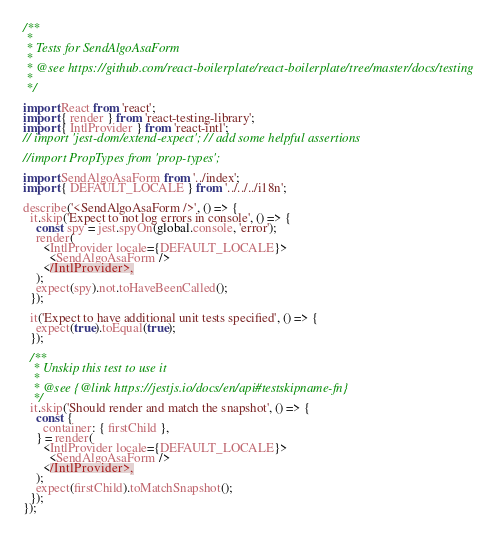Convert code to text. <code><loc_0><loc_0><loc_500><loc_500><_JavaScript_>/**
 *
 * Tests for SendAlgoAsaForm
 *
 * @see https://github.com/react-boilerplate/react-boilerplate/tree/master/docs/testing
 *
 */

import React from 'react';
import { render } from 'react-testing-library';
import { IntlProvider } from 'react-intl';
// import 'jest-dom/extend-expect'; // add some helpful assertions

//import PropTypes from 'prop-types';

import SendAlgoAsaForm from '../index';
import { DEFAULT_LOCALE } from '../../../i18n';

describe('<SendAlgoAsaForm />', () => {
  it.skip('Expect to not log errors in console', () => {
    const spy = jest.spyOn(global.console, 'error');
    render(
      <IntlProvider locale={DEFAULT_LOCALE}>
        <SendAlgoAsaForm />
      </IntlProvider>,
    );
    expect(spy).not.toHaveBeenCalled();
  });

  it('Expect to have additional unit tests specified', () => {
    expect(true).toEqual(true);
  });

  /**
   * Unskip this test to use it
   *
   * @see {@link https://jestjs.io/docs/en/api#testskipname-fn}
   */
  it.skip('Should render and match the snapshot', () => {
    const {
      container: { firstChild },
    } = render(
      <IntlProvider locale={DEFAULT_LOCALE}>
        <SendAlgoAsaForm />
      </IntlProvider>,
    );
    expect(firstChild).toMatchSnapshot();
  });
});
</code> 